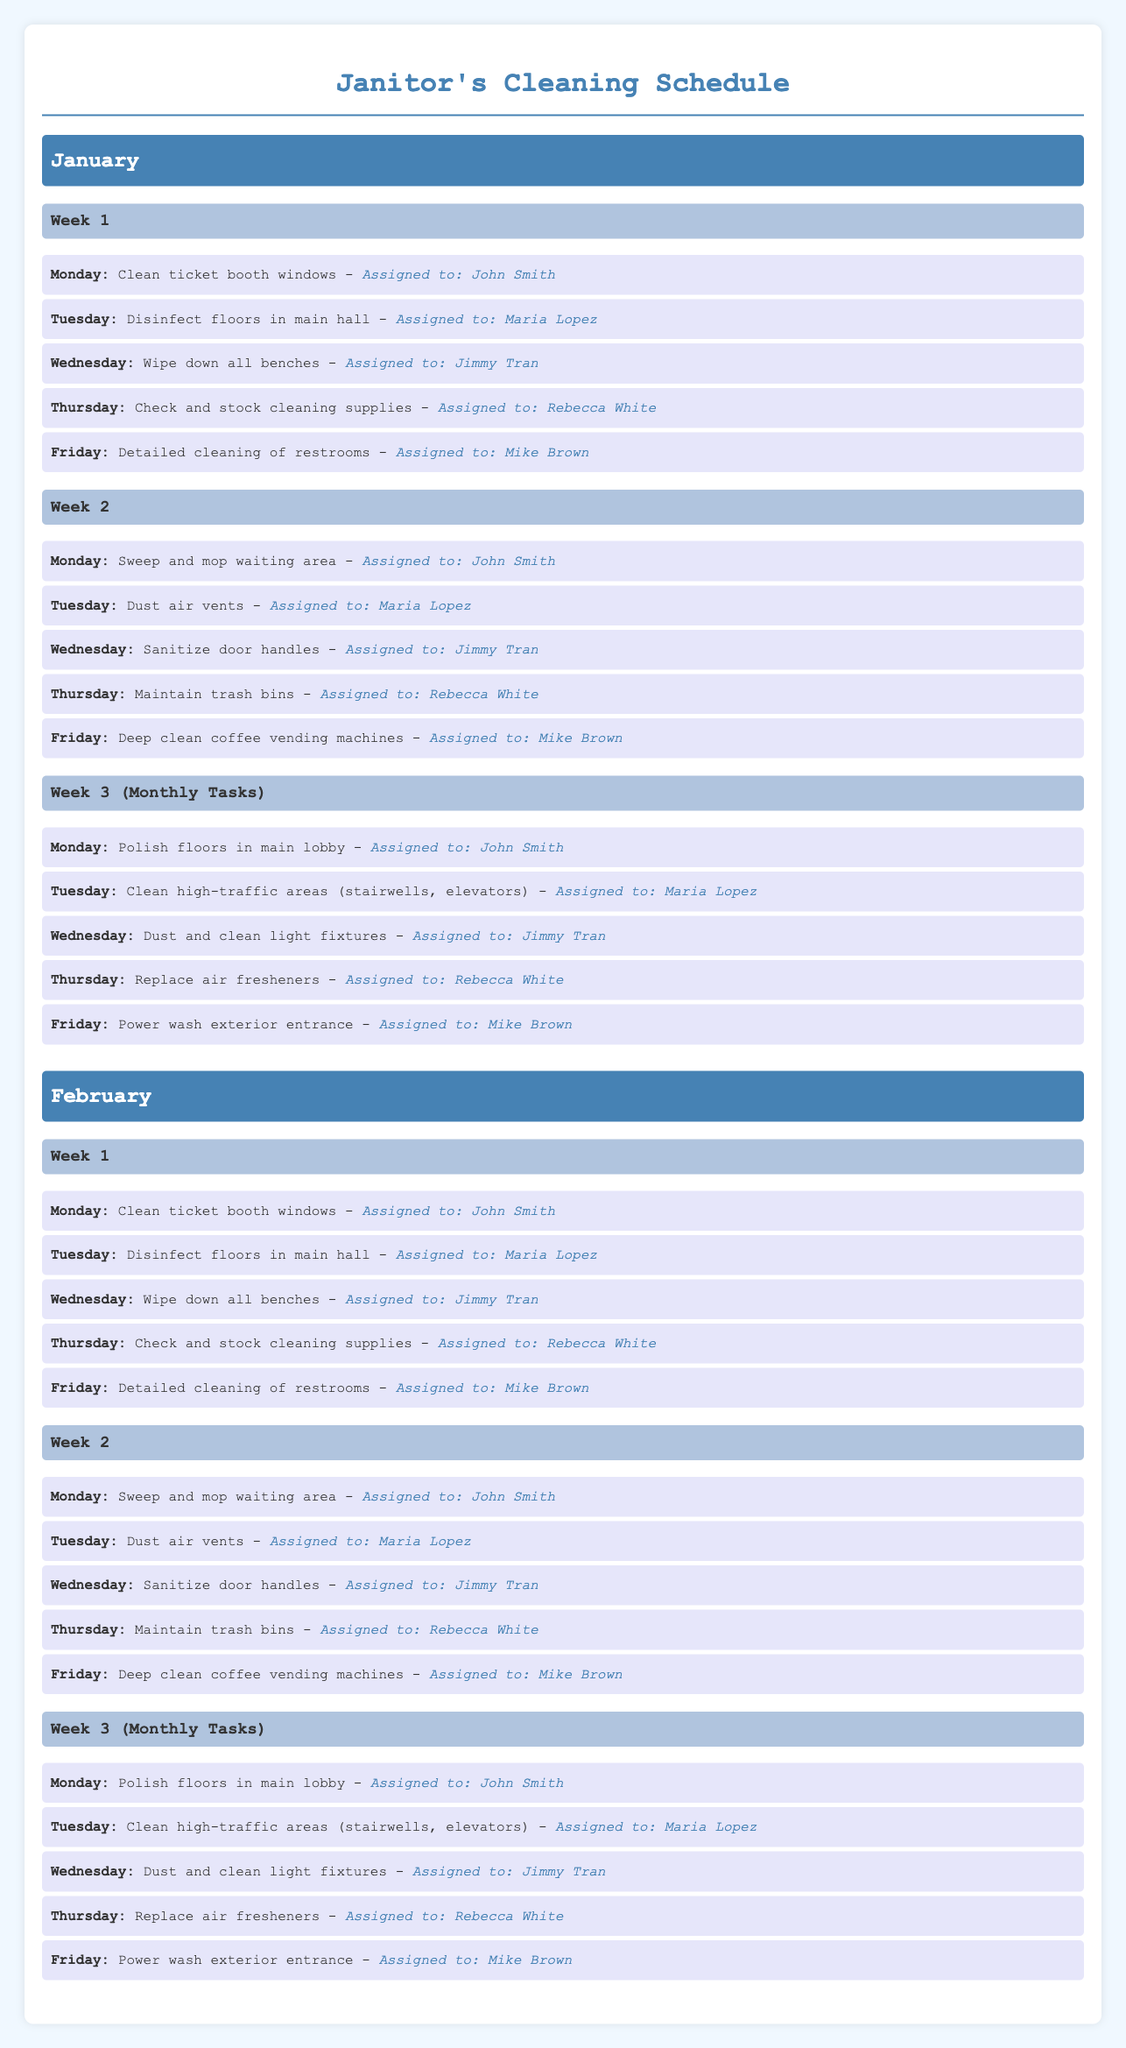what task is assigned to John Smith on the first Monday of January? The task assigned to John Smith on the first Monday of January is to clean ticket booth windows.
Answer: Clean ticket booth windows who is responsible for sanitizing door handles in February? The person responsible for sanitizing door handles in February is Jimmy Tran.
Answer: Jimmy Tran how many weeks have monthly tasks in January? There is one week in January that has monthly tasks, specifically in Week 3.
Answer: 1 which task is performed on the first Friday of February? The task performed on the first Friday of February is detailed cleaning of restrooms.
Answer: Detailed cleaning of restrooms what color is the background of the document? The background color of the document is light blue (#f0f8ff).
Answer: light blue who checks and stocks cleaning supplies in Week 1? The person who checks and stocks cleaning supplies in Week 1 is Rebecca White.
Answer: Rebecca White how many days are allocated to cleaning the ticket booth windows? Cleaning the ticket booth windows is scheduled for two days, January and February's first Mondays.
Answer: 2 what is the task scheduled for the last Friday of January? The task scheduled for the last Friday of January is to power wash exterior entrance.
Answer: Power wash exterior entrance 